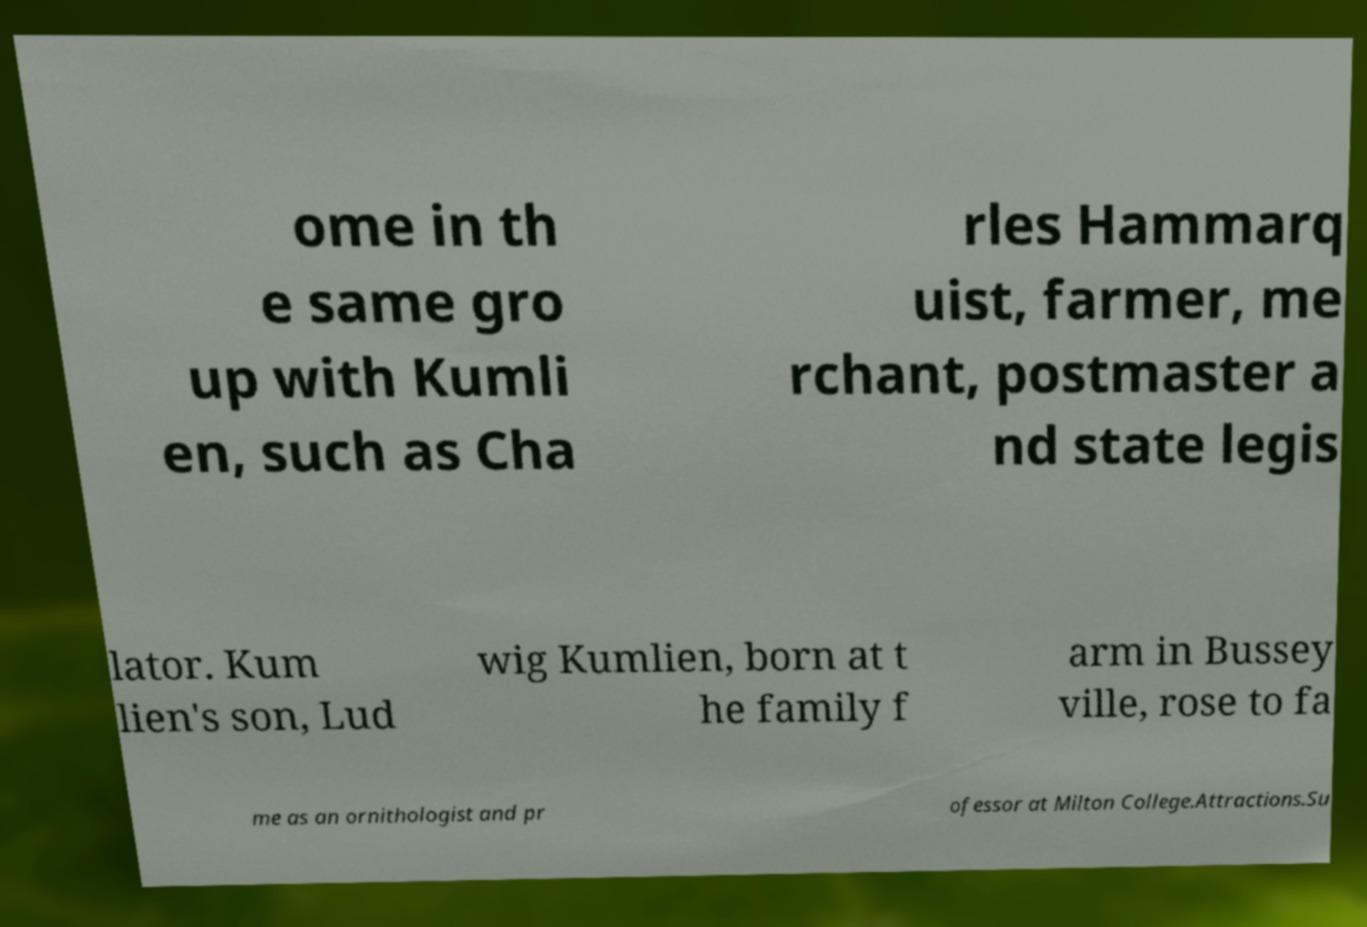Can you read and provide the text displayed in the image?This photo seems to have some interesting text. Can you extract and type it out for me? ome in th e same gro up with Kumli en, such as Cha rles Hammarq uist, farmer, me rchant, postmaster a nd state legis lator. Kum lien's son, Lud wig Kumlien, born at t he family f arm in Bussey ville, rose to fa me as an ornithologist and pr ofessor at Milton College.Attractions.Su 